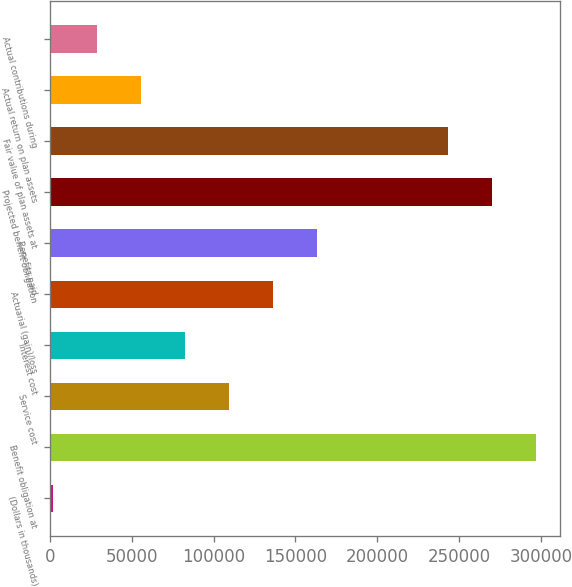<chart> <loc_0><loc_0><loc_500><loc_500><bar_chart><fcel>(Dollars in thousands)<fcel>Benefit obligation at<fcel>Service cost<fcel>Interest cost<fcel>Actuarial (gain)/loss<fcel>Benefits paid<fcel>Projected benefit obligation<fcel>Fair value of plan assets at<fcel>Actual return on plan assets<fcel>Actual contributions during<nl><fcel>2015<fcel>296870<fcel>109235<fcel>82430<fcel>136040<fcel>162845<fcel>270065<fcel>243260<fcel>55625<fcel>28820<nl></chart> 